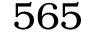Convert formula to latex. <formula><loc_0><loc_0><loc_500><loc_500>5 6 5</formula> 